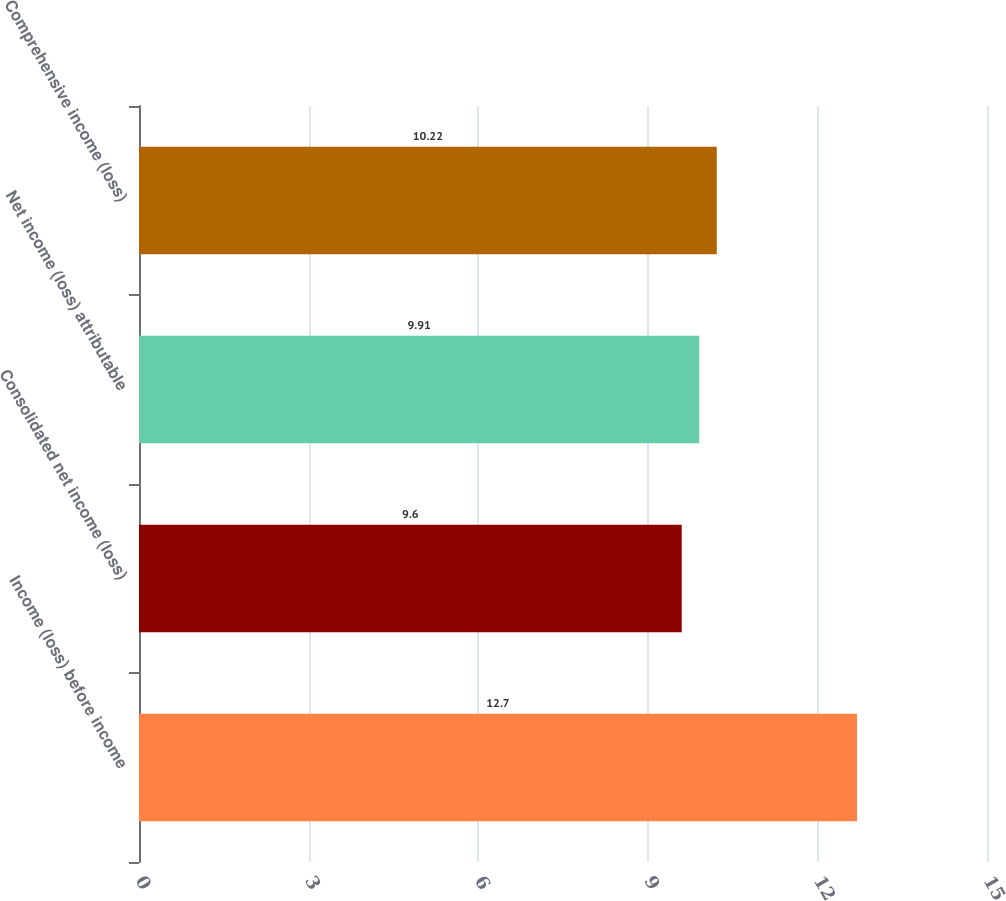<chart> <loc_0><loc_0><loc_500><loc_500><bar_chart><fcel>Income (loss) before income<fcel>Consolidated net income (loss)<fcel>Net income (loss) attributable<fcel>Comprehensive income (loss)<nl><fcel>12.7<fcel>9.6<fcel>9.91<fcel>10.22<nl></chart> 